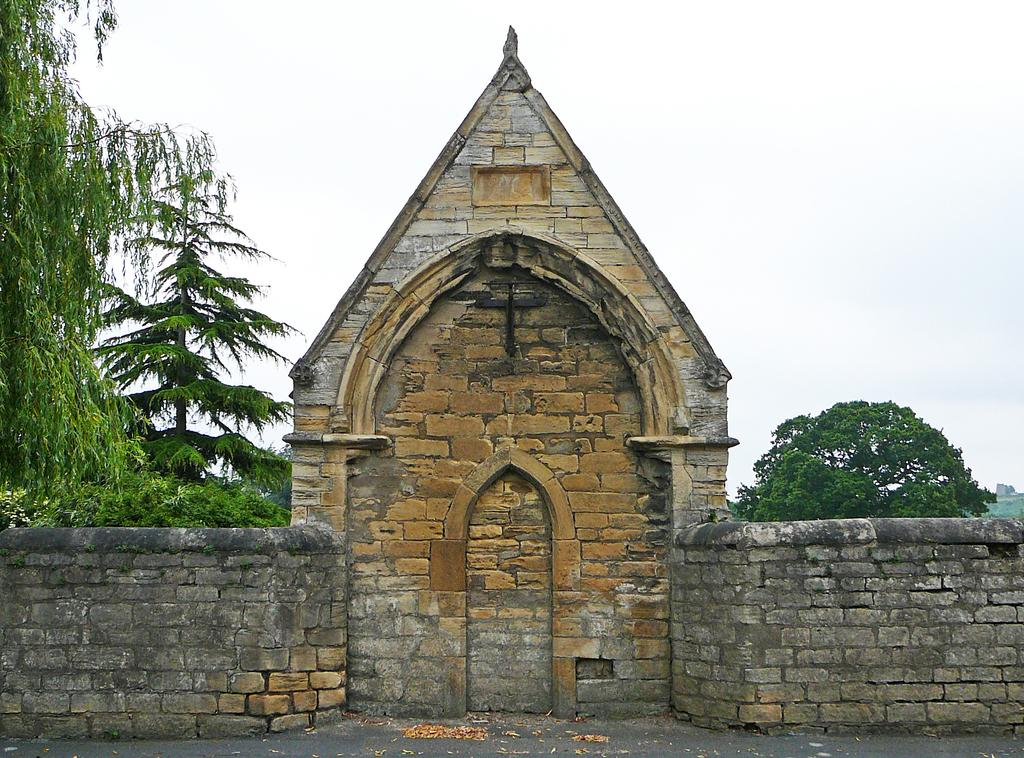What architectural feature is present in the image? There is a wall with an arch in the image. What is attached to the wall? There is a cross attached to the wall. What can be seen in the background of the image? There are trees and the sky visible in the background of the image. How many clovers can be seen growing near the wall in the image? There are no clovers visible in the image. What type of humor is being displayed by the cross in the image? The cross is an object of religious significance and does not display humor in the image. 